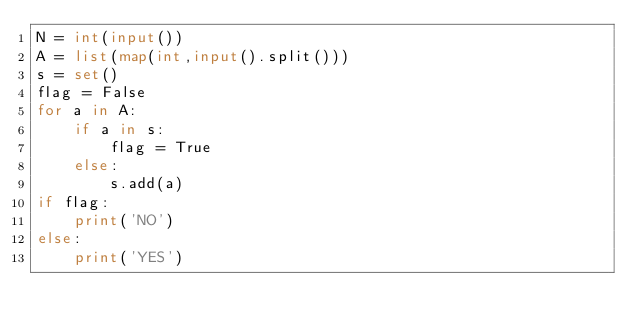Convert code to text. <code><loc_0><loc_0><loc_500><loc_500><_Python_>N = int(input())
A = list(map(int,input().split()))
s = set()
flag = False
for a in A:
    if a in s:
        flag = True
    else:
        s.add(a)
if flag:
    print('NO')
else:
    print('YES')</code> 